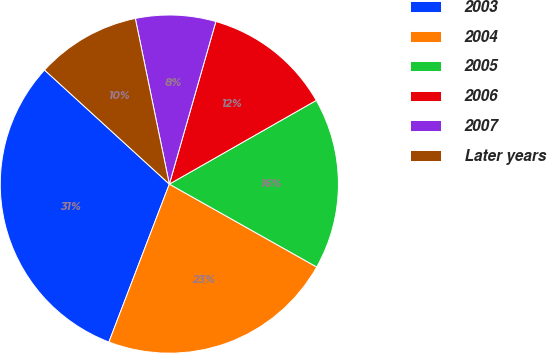<chart> <loc_0><loc_0><loc_500><loc_500><pie_chart><fcel>2003<fcel>2004<fcel>2005<fcel>2006<fcel>2007<fcel>Later years<nl><fcel>30.97%<fcel>22.66%<fcel>16.4%<fcel>12.32%<fcel>7.66%<fcel>9.99%<nl></chart> 